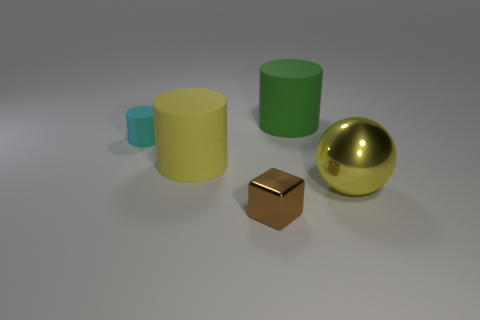What number of large yellow matte things are there?
Provide a succinct answer. 1. Does the big green matte object have the same shape as the small object that is right of the small cyan matte thing?
Your answer should be very brief. No. How many objects are either brown shiny objects or matte cylinders that are behind the yellow rubber cylinder?
Your answer should be very brief. 3. What is the material of the other big object that is the same shape as the big green object?
Make the answer very short. Rubber. There is a yellow object that is behind the large yellow shiny thing; is its shape the same as the green matte thing?
Make the answer very short. Yes. Is there anything else that has the same size as the yellow rubber cylinder?
Your response must be concise. Yes. Is the number of brown metal cubes behind the yellow shiny object less than the number of cyan objects that are behind the small cyan matte thing?
Your response must be concise. No. What number of other things are the same shape as the brown metal object?
Your answer should be very brief. 0. There is a object in front of the metallic object that is behind the small thing in front of the yellow metallic sphere; how big is it?
Provide a short and direct response. Small. How many yellow objects are small cubes or shiny balls?
Your answer should be compact. 1. 